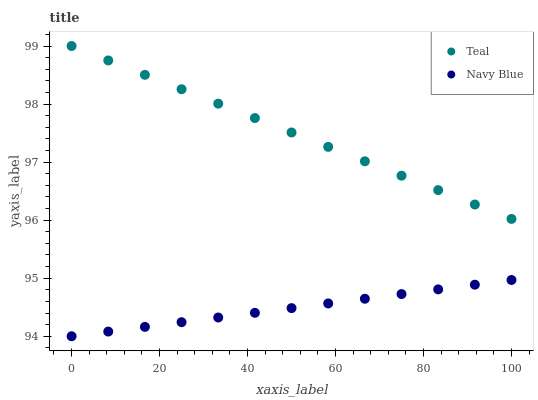Does Navy Blue have the minimum area under the curve?
Answer yes or no. Yes. Does Teal have the maximum area under the curve?
Answer yes or no. Yes. Does Teal have the minimum area under the curve?
Answer yes or no. No. Is Navy Blue the smoothest?
Answer yes or no. Yes. Is Teal the roughest?
Answer yes or no. Yes. Is Teal the smoothest?
Answer yes or no. No. Does Navy Blue have the lowest value?
Answer yes or no. Yes. Does Teal have the lowest value?
Answer yes or no. No. Does Teal have the highest value?
Answer yes or no. Yes. Is Navy Blue less than Teal?
Answer yes or no. Yes. Is Teal greater than Navy Blue?
Answer yes or no. Yes. Does Navy Blue intersect Teal?
Answer yes or no. No. 